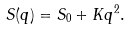Convert formula to latex. <formula><loc_0><loc_0><loc_500><loc_500>S ( q ) = S _ { 0 } + K q ^ { 2 } .</formula> 